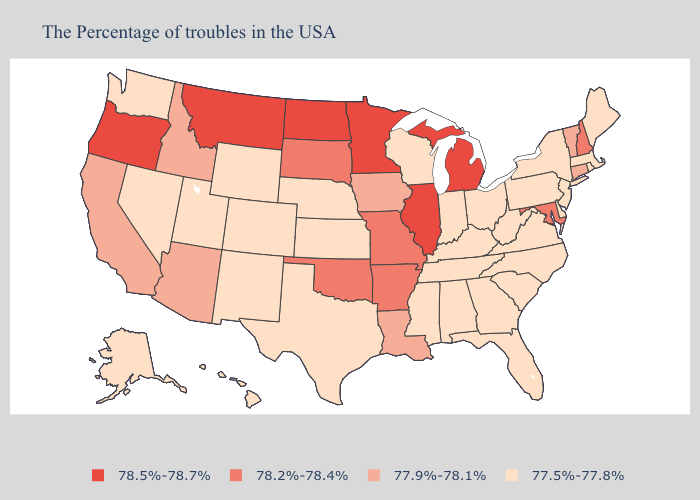Does Kansas have a lower value than Tennessee?
Give a very brief answer. No. What is the lowest value in states that border Pennsylvania?
Be succinct. 77.5%-77.8%. Does Arkansas have the highest value in the South?
Keep it brief. Yes. What is the highest value in the South ?
Short answer required. 78.2%-78.4%. Which states have the lowest value in the USA?
Write a very short answer. Maine, Massachusetts, Rhode Island, New York, New Jersey, Delaware, Pennsylvania, Virginia, North Carolina, South Carolina, West Virginia, Ohio, Florida, Georgia, Kentucky, Indiana, Alabama, Tennessee, Wisconsin, Mississippi, Kansas, Nebraska, Texas, Wyoming, Colorado, New Mexico, Utah, Nevada, Washington, Alaska, Hawaii. Name the states that have a value in the range 77.9%-78.1%?
Answer briefly. Vermont, Connecticut, Louisiana, Iowa, Arizona, Idaho, California. What is the value of Alabama?
Give a very brief answer. 77.5%-77.8%. Name the states that have a value in the range 77.9%-78.1%?
Short answer required. Vermont, Connecticut, Louisiana, Iowa, Arizona, Idaho, California. Does Florida have a lower value than Indiana?
Give a very brief answer. No. What is the lowest value in the West?
Concise answer only. 77.5%-77.8%. Does the map have missing data?
Keep it brief. No. What is the highest value in the West ?
Concise answer only. 78.5%-78.7%. Does Washington have the same value as Virginia?
Give a very brief answer. Yes. Does Georgia have the lowest value in the South?
Keep it brief. Yes. 